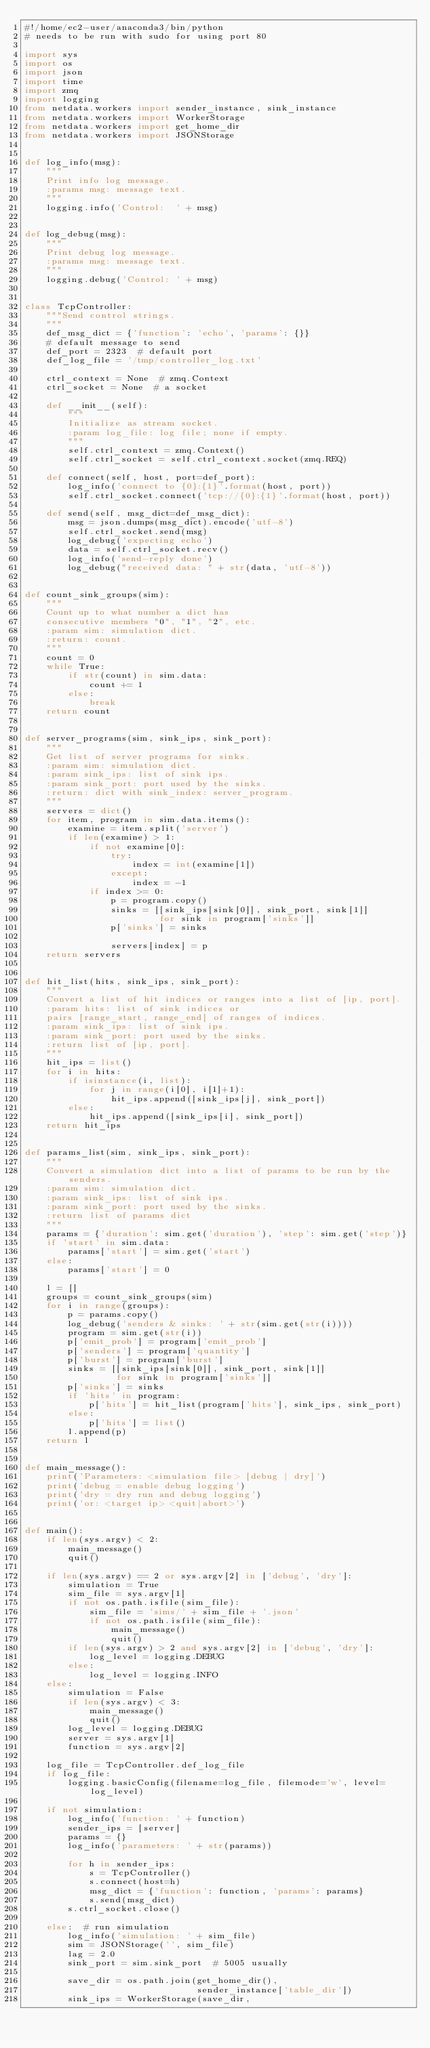<code> <loc_0><loc_0><loc_500><loc_500><_Python_>#!/home/ec2-user/anaconda3/bin/python
# needs to be run with sudo for using port 80

import sys
import os
import json
import time
import zmq
import logging
from netdata.workers import sender_instance, sink_instance
from netdata.workers import WorkerStorage
from netdata.workers import get_home_dir
from netdata.workers import JSONStorage


def log_info(msg):
    """
    Print info log message.
    :params msg: message text.
    """
    logging.info('Control:  ' + msg)


def log_debug(msg):
    """
    Print debug log message.
    :params msg: message text.
    """
    logging.debug('Control: ' + msg)


class TcpController:
    """Send control strings.
    """
    def_msg_dict = {'function': 'echo', 'params': {}}  
    # default message to send
    def_port = 2323  # default port
    def_log_file = '/tmp/controller_log.txt'

    ctrl_context = None  # zmq.Context
    ctrl_socket = None  # a socket

    def __init__(self):
        """
        Initialize as stream socket.
        :param log_file: log file; none if empty.
        """
        self.ctrl_context = zmq.Context()
        self.ctrl_socket = self.ctrl_context.socket(zmq.REQ)

    def connect(self, host, port=def_port):
        log_info('connect to {0}:{1}'.format(host, port))
        self.ctrl_socket.connect('tcp://{0}:{1}'.format(host, port))

    def send(self, msg_dict=def_msg_dict):
        msg = json.dumps(msg_dict).encode('utf-8')
        self.ctrl_socket.send(msg)
        log_debug('expecting echo')
        data = self.ctrl_socket.recv()
        log_info('send-reply done')
        log_debug("received data: " + str(data, 'utf-8'))


def count_sink_groups(sim):
    """
    Count up to what number a dict has
    consecutive members "0", "1", "2", etc.
    :param sim: simulation dict.
    :return: count.
    """
    count = 0
    while True:
        if str(count) in sim.data:
            count += 1
        else:
            break
    return count


def server_programs(sim, sink_ips, sink_port):
    """
    Get list of server programs for sinks.
    :param sim: simulation dict.
    :param sink_ips: list of sink ips.
    :param sink_port: port used by the sinks.
    :return: dict with sink_index: server_program.
    """
    servers = dict()
    for item, program in sim.data.items():
        examine = item.split('server')
        if len(examine) > 1:
            if not examine[0]:
                try:
                    index = int(examine[1])
                except:
                    index = -1
            if index >= 0:
                p = program.copy()
                sinks = [[sink_ips[sink[0]], sink_port, sink[1]]
                         for sink in program['sinks']]
                p['sinks'] = sinks

                servers[index] = p
    return servers


def hit_list(hits, sink_ips, sink_port):
    """
    Convert a list of hit indices or ranges into a list of [ip, port].
    :param hits: list of sink indices or
    pairs [range_start, range_end] of ranges of indices.
    :param sink_ips: list of sink ips.
    :param sink_port: port used by the sinks.
    :return list of [ip, port].
    """
    hit_ips = list()
    for i in hits:
        if isinstance(i, list):
            for j in range(i[0], i[1]+1):
                hit_ips.append([sink_ips[j], sink_port])
        else:
            hit_ips.append([sink_ips[i], sink_port])
    return hit_ips

     
def params_list(sim, sink_ips, sink_port):
    """
    Convert a simulation dict into a list of params to be run by the senders.
    :param sim: simulation dict.
    :param sink_ips: list of sink ips.
    :param sink_port: port used by the sinks.
    :return list of params dict
    """
    params = {'duration': sim.get('duration'), 'step': sim.get('step')}
    if 'start' in sim.data:
        params['start'] = sim.get('start')
    else:
        params['start'] = 0

    l = []
    groups = count_sink_groups(sim)
    for i in range(groups):
        p = params.copy()
        log_debug('senders & sinks: ' + str(sim.get(str(i))))
        program = sim.get(str(i))
        p['emit_prob'] = program['emit_prob']
        p['senders'] = program['quantity']
        p['burst'] = program['burst']
        sinks = [[sink_ips[sink[0]], sink_port, sink[1]]
                 for sink in program['sinks']]
        p['sinks'] = sinks
        if 'hits' in program:
            p['hits'] = hit_list(program['hits'], sink_ips, sink_port)
        else:
            p['hits'] = list()
        l.append(p)
    return l


def main_message():
    print('Parameters: <simulation file> [debug | dry]')
    print('debug = enable debug logging')
    print('dry = dry run and debug logging')
    print('or: <target ip> <quit|abort>')


def main():
    if len(sys.argv) < 2:
        main_message()
        quit()

    if len(sys.argv) == 2 or sys.argv[2] in ['debug', 'dry']:
        simulation = True
        sim_file = sys.argv[1]
        if not os.path.isfile(sim_file):
            sim_file = 'sims/' + sim_file + '.json'
            if not os.path.isfile(sim_file):
                main_message()
                quit()
        if len(sys.argv) > 2 and sys.argv[2] in ['debug', 'dry']:
            log_level = logging.DEBUG
        else:
            log_level = logging.INFO
    else:
        simulation = False
        if len(sys.argv) < 3:
            main_message()
            quit()
        log_level = logging.DEBUG
        server = sys.argv[1]
        function = sys.argv[2]

    log_file = TcpController.def_log_file
    if log_file:
        logging.basicConfig(filename=log_file, filemode='w', level=log_level)

    if not simulation:
        log_info('function: ' + function)
        sender_ips = [server]
        params = {}
        log_info('parameters: ' + str(params))

        for h in sender_ips:
            s = TcpController()
            s.connect(host=h)
            msg_dict = {'function': function, 'params': params}
            s.send(msg_dict)
        s.ctrl_socket.close()

    else:  # run simulation
        log_info('simulation: ' + sim_file)
        sim = JSONStorage('', sim_file)
        lag = 2.0
        sink_port = sim.sink_port  # 5005 usually

        save_dir = os.path.join(get_home_dir(),
                                sender_instance['table_dir'])
        sink_ips = WorkerStorage(save_dir,</code> 